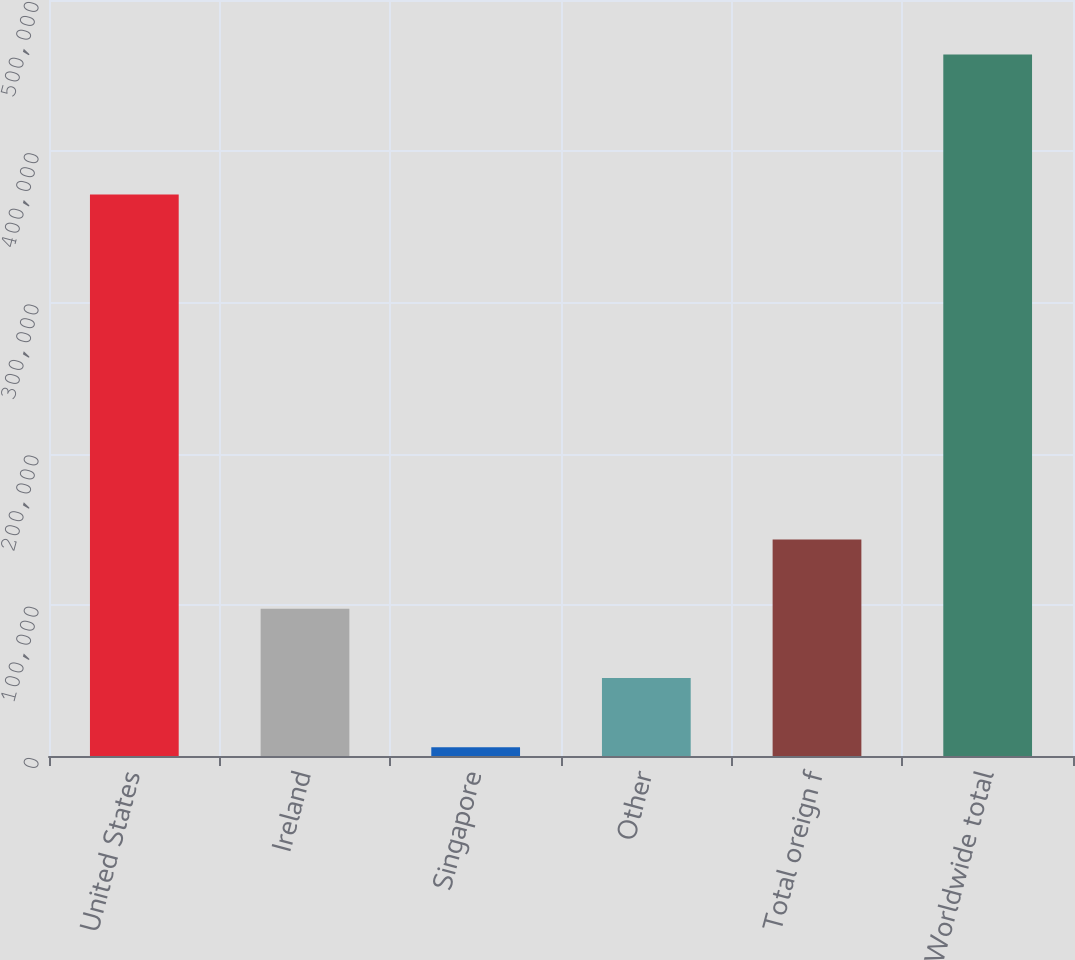Convert chart to OTSL. <chart><loc_0><loc_0><loc_500><loc_500><bar_chart><fcel>United States<fcel>Ireland<fcel>Singapore<fcel>Other<fcel>Total oreign f<fcel>Worldwide total<nl><fcel>371380<fcel>97380.6<fcel>5743<fcel>51561.8<fcel>143199<fcel>463931<nl></chart> 